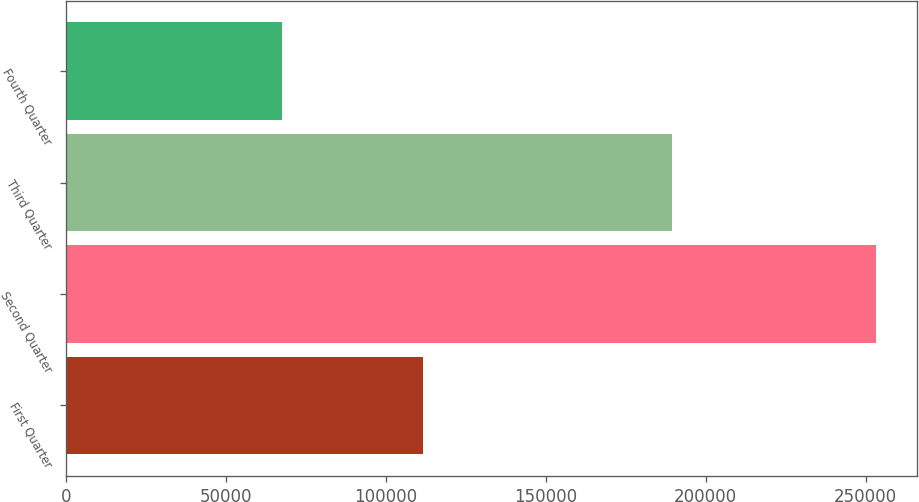<chart> <loc_0><loc_0><loc_500><loc_500><bar_chart><fcel>First Quarter<fcel>Second Quarter<fcel>Third Quarter<fcel>Fourth Quarter<nl><fcel>111606<fcel>253325<fcel>189506<fcel>67610<nl></chart> 